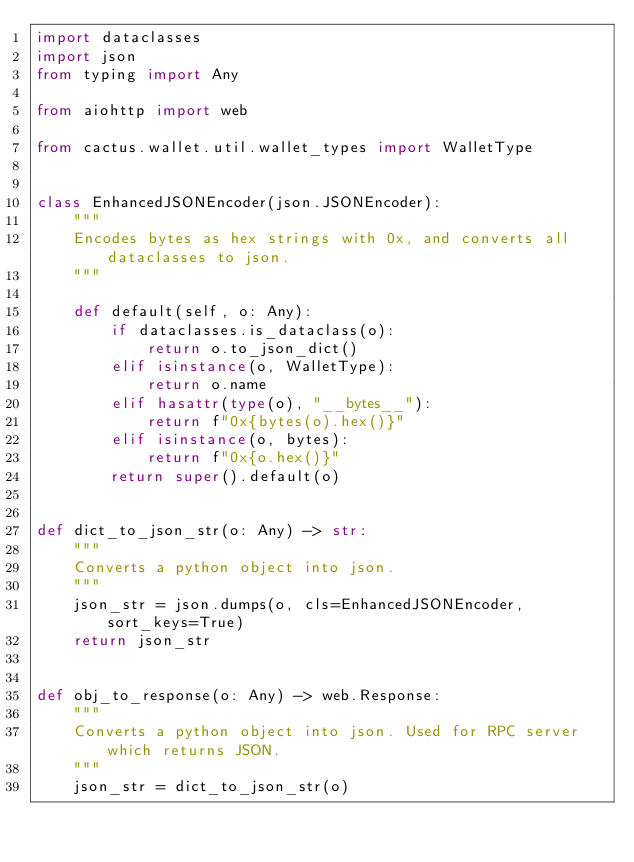<code> <loc_0><loc_0><loc_500><loc_500><_Python_>import dataclasses
import json
from typing import Any

from aiohttp import web

from cactus.wallet.util.wallet_types import WalletType


class EnhancedJSONEncoder(json.JSONEncoder):
    """
    Encodes bytes as hex strings with 0x, and converts all dataclasses to json.
    """

    def default(self, o: Any):
        if dataclasses.is_dataclass(o):
            return o.to_json_dict()
        elif isinstance(o, WalletType):
            return o.name
        elif hasattr(type(o), "__bytes__"):
            return f"0x{bytes(o).hex()}"
        elif isinstance(o, bytes):
            return f"0x{o.hex()}"
        return super().default(o)


def dict_to_json_str(o: Any) -> str:
    """
    Converts a python object into json.
    """
    json_str = json.dumps(o, cls=EnhancedJSONEncoder, sort_keys=True)
    return json_str


def obj_to_response(o: Any) -> web.Response:
    """
    Converts a python object into json. Used for RPC server which returns JSON.
    """
    json_str = dict_to_json_str(o)</code> 